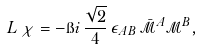Convert formula to latex. <formula><loc_0><loc_0><loc_500><loc_500>L \, \chi = - \i i \, \frac { \sqrt { 2 } } { 4 } \, \epsilon _ { A B } \, \bar { \mathcal { M } } ^ { A } \mathcal { M } ^ { B } ,</formula> 